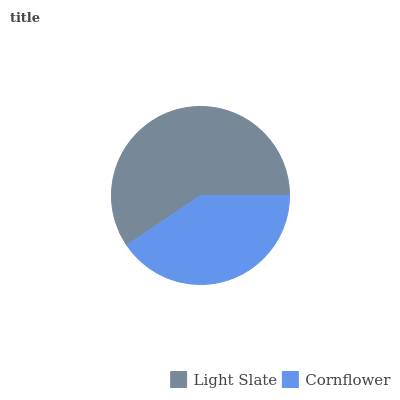Is Cornflower the minimum?
Answer yes or no. Yes. Is Light Slate the maximum?
Answer yes or no. Yes. Is Cornflower the maximum?
Answer yes or no. No. Is Light Slate greater than Cornflower?
Answer yes or no. Yes. Is Cornflower less than Light Slate?
Answer yes or no. Yes. Is Cornflower greater than Light Slate?
Answer yes or no. No. Is Light Slate less than Cornflower?
Answer yes or no. No. Is Light Slate the high median?
Answer yes or no. Yes. Is Cornflower the low median?
Answer yes or no. Yes. Is Cornflower the high median?
Answer yes or no. No. Is Light Slate the low median?
Answer yes or no. No. 